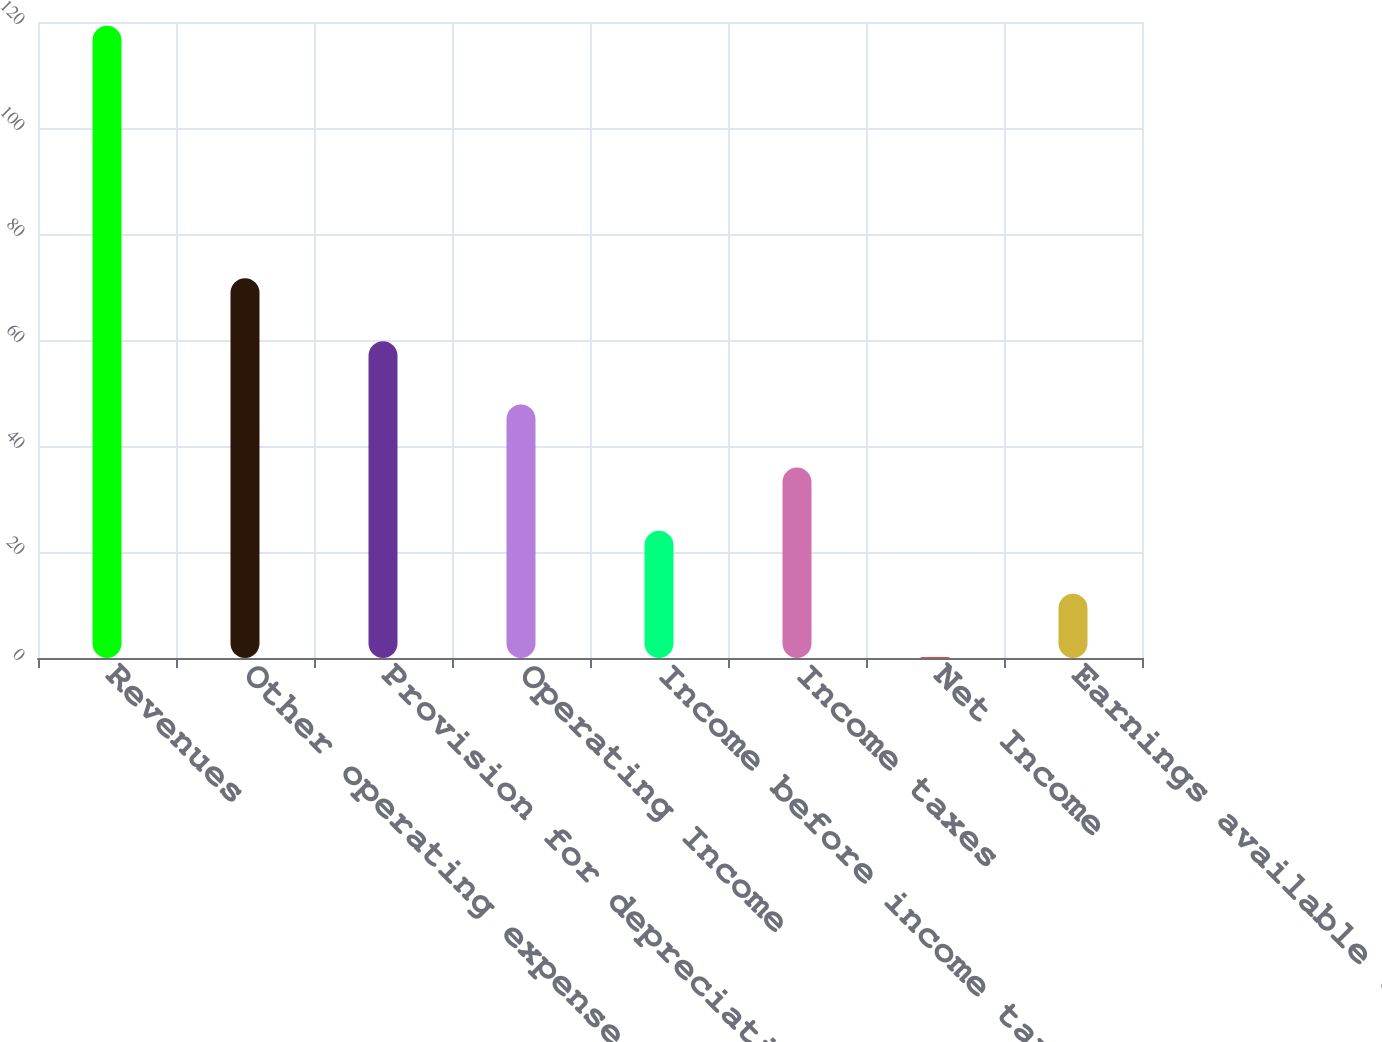Convert chart to OTSL. <chart><loc_0><loc_0><loc_500><loc_500><bar_chart><fcel>Revenues<fcel>Other operating expense<fcel>Provision for depreciation<fcel>Operating Income<fcel>Income before income taxes<fcel>Income taxes<fcel>Net Income<fcel>Earnings available to Parent<nl><fcel>119.3<fcel>71.66<fcel>59.75<fcel>47.84<fcel>24.02<fcel>35.93<fcel>0.2<fcel>12.11<nl></chart> 